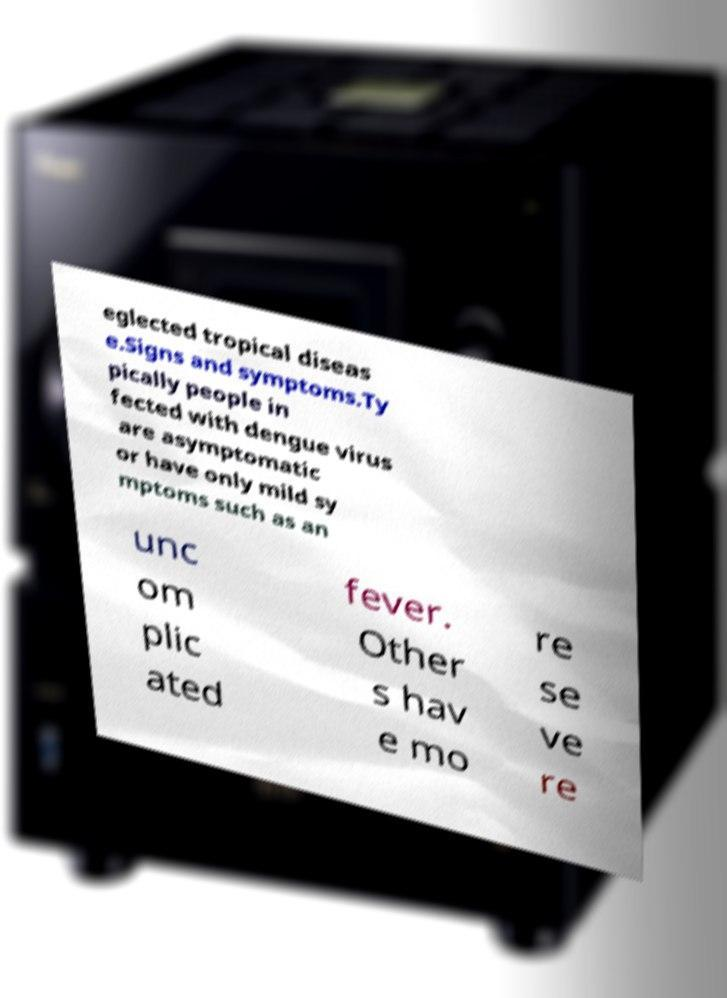Could you extract and type out the text from this image? eglected tropical diseas e.Signs and symptoms.Ty pically people in fected with dengue virus are asymptomatic or have only mild sy mptoms such as an unc om plic ated fever. Other s hav e mo re se ve re 